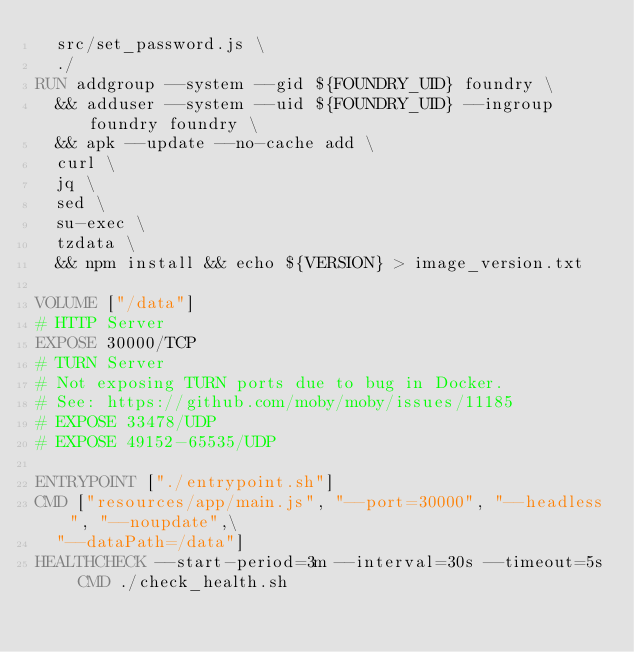Convert code to text. <code><loc_0><loc_0><loc_500><loc_500><_Dockerfile_>  src/set_password.js \
  ./
RUN addgroup --system --gid ${FOUNDRY_UID} foundry \
  && adduser --system --uid ${FOUNDRY_UID} --ingroup foundry foundry \
  && apk --update --no-cache add \
  curl \
  jq \
  sed \
  su-exec \
  tzdata \
  && npm install && echo ${VERSION} > image_version.txt

VOLUME ["/data"]
# HTTP Server
EXPOSE 30000/TCP
# TURN Server
# Not exposing TURN ports due to bug in Docker.
# See: https://github.com/moby/moby/issues/11185
# EXPOSE 33478/UDP
# EXPOSE 49152-65535/UDP

ENTRYPOINT ["./entrypoint.sh"]
CMD ["resources/app/main.js", "--port=30000", "--headless", "--noupdate",\
  "--dataPath=/data"]
HEALTHCHECK --start-period=3m --interval=30s --timeout=5s CMD ./check_health.sh
</code> 